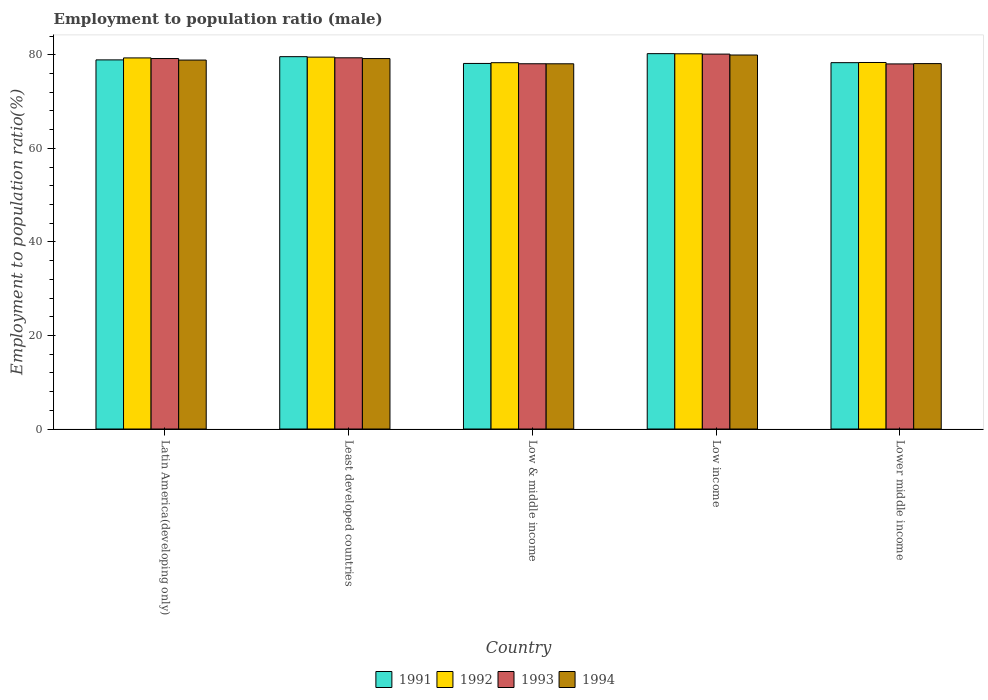How many groups of bars are there?
Offer a very short reply. 5. Are the number of bars per tick equal to the number of legend labels?
Ensure brevity in your answer.  Yes. How many bars are there on the 2nd tick from the right?
Give a very brief answer. 4. What is the label of the 5th group of bars from the left?
Provide a short and direct response. Lower middle income. In how many cases, is the number of bars for a given country not equal to the number of legend labels?
Offer a very short reply. 0. What is the employment to population ratio in 1991 in Lower middle income?
Offer a very short reply. 78.3. Across all countries, what is the maximum employment to population ratio in 1993?
Offer a very short reply. 80.14. Across all countries, what is the minimum employment to population ratio in 1993?
Offer a terse response. 78.04. In which country was the employment to population ratio in 1994 minimum?
Ensure brevity in your answer.  Low & middle income. What is the total employment to population ratio in 1992 in the graph?
Make the answer very short. 395.65. What is the difference between the employment to population ratio in 1993 in Least developed countries and that in Lower middle income?
Your response must be concise. 1.31. What is the difference between the employment to population ratio in 1993 in Low & middle income and the employment to population ratio in 1992 in Lower middle income?
Ensure brevity in your answer.  -0.27. What is the average employment to population ratio in 1991 per country?
Your answer should be compact. 79.03. What is the difference between the employment to population ratio of/in 1992 and employment to population ratio of/in 1993 in Latin America(developing only)?
Give a very brief answer. 0.14. What is the ratio of the employment to population ratio in 1991 in Low & middle income to that in Low income?
Your answer should be compact. 0.97. Is the difference between the employment to population ratio in 1992 in Low income and Lower middle income greater than the difference between the employment to population ratio in 1993 in Low income and Lower middle income?
Your response must be concise. No. What is the difference between the highest and the second highest employment to population ratio in 1993?
Give a very brief answer. 0.95. What is the difference between the highest and the lowest employment to population ratio in 1994?
Your answer should be compact. 1.88. In how many countries, is the employment to population ratio in 1991 greater than the average employment to population ratio in 1991 taken over all countries?
Offer a terse response. 2. Is the sum of the employment to population ratio in 1991 in Latin America(developing only) and Lower middle income greater than the maximum employment to population ratio in 1993 across all countries?
Provide a succinct answer. Yes. What does the 3rd bar from the left in Least developed countries represents?
Make the answer very short. 1993. Does the graph contain grids?
Your response must be concise. No. What is the title of the graph?
Ensure brevity in your answer.  Employment to population ratio (male). Does "1990" appear as one of the legend labels in the graph?
Your answer should be very brief. No. What is the label or title of the Y-axis?
Your answer should be compact. Employment to population ratio(%). What is the Employment to population ratio(%) of 1991 in Latin America(developing only)?
Make the answer very short. 78.9. What is the Employment to population ratio(%) of 1992 in Latin America(developing only)?
Give a very brief answer. 79.32. What is the Employment to population ratio(%) of 1993 in Latin America(developing only)?
Provide a short and direct response. 79.19. What is the Employment to population ratio(%) of 1994 in Latin America(developing only)?
Provide a succinct answer. 78.86. What is the Employment to population ratio(%) of 1991 in Least developed countries?
Provide a short and direct response. 79.59. What is the Employment to population ratio(%) in 1992 in Least developed countries?
Offer a very short reply. 79.49. What is the Employment to population ratio(%) of 1993 in Least developed countries?
Keep it short and to the point. 79.34. What is the Employment to population ratio(%) of 1994 in Least developed countries?
Your answer should be very brief. 79.18. What is the Employment to population ratio(%) in 1991 in Low & middle income?
Your answer should be compact. 78.14. What is the Employment to population ratio(%) of 1992 in Low & middle income?
Provide a short and direct response. 78.3. What is the Employment to population ratio(%) of 1993 in Low & middle income?
Your response must be concise. 78.07. What is the Employment to population ratio(%) of 1994 in Low & middle income?
Provide a short and direct response. 78.06. What is the Employment to population ratio(%) in 1991 in Low income?
Keep it short and to the point. 80.23. What is the Employment to population ratio(%) in 1992 in Low income?
Keep it short and to the point. 80.2. What is the Employment to population ratio(%) of 1993 in Low income?
Ensure brevity in your answer.  80.14. What is the Employment to population ratio(%) in 1994 in Low income?
Your answer should be compact. 79.94. What is the Employment to population ratio(%) of 1991 in Lower middle income?
Your answer should be compact. 78.3. What is the Employment to population ratio(%) in 1992 in Lower middle income?
Your answer should be very brief. 78.34. What is the Employment to population ratio(%) in 1993 in Lower middle income?
Give a very brief answer. 78.04. What is the Employment to population ratio(%) of 1994 in Lower middle income?
Your answer should be very brief. 78.11. Across all countries, what is the maximum Employment to population ratio(%) in 1991?
Your answer should be compact. 80.23. Across all countries, what is the maximum Employment to population ratio(%) of 1992?
Give a very brief answer. 80.2. Across all countries, what is the maximum Employment to population ratio(%) of 1993?
Your response must be concise. 80.14. Across all countries, what is the maximum Employment to population ratio(%) in 1994?
Your response must be concise. 79.94. Across all countries, what is the minimum Employment to population ratio(%) in 1991?
Keep it short and to the point. 78.14. Across all countries, what is the minimum Employment to population ratio(%) in 1992?
Your answer should be very brief. 78.3. Across all countries, what is the minimum Employment to population ratio(%) in 1993?
Keep it short and to the point. 78.04. Across all countries, what is the minimum Employment to population ratio(%) in 1994?
Offer a very short reply. 78.06. What is the total Employment to population ratio(%) in 1991 in the graph?
Keep it short and to the point. 395.16. What is the total Employment to population ratio(%) of 1992 in the graph?
Keep it short and to the point. 395.65. What is the total Employment to population ratio(%) of 1993 in the graph?
Offer a very short reply. 394.78. What is the total Employment to population ratio(%) in 1994 in the graph?
Provide a short and direct response. 394.15. What is the difference between the Employment to population ratio(%) in 1991 in Latin America(developing only) and that in Least developed countries?
Your answer should be very brief. -0.69. What is the difference between the Employment to population ratio(%) in 1992 in Latin America(developing only) and that in Least developed countries?
Ensure brevity in your answer.  -0.17. What is the difference between the Employment to population ratio(%) of 1993 in Latin America(developing only) and that in Least developed countries?
Provide a succinct answer. -0.16. What is the difference between the Employment to population ratio(%) of 1994 in Latin America(developing only) and that in Least developed countries?
Provide a short and direct response. -0.32. What is the difference between the Employment to population ratio(%) of 1991 in Latin America(developing only) and that in Low & middle income?
Your answer should be very brief. 0.76. What is the difference between the Employment to population ratio(%) of 1992 in Latin America(developing only) and that in Low & middle income?
Make the answer very short. 1.02. What is the difference between the Employment to population ratio(%) of 1993 in Latin America(developing only) and that in Low & middle income?
Provide a succinct answer. 1.11. What is the difference between the Employment to population ratio(%) in 1994 in Latin America(developing only) and that in Low & middle income?
Your response must be concise. 0.79. What is the difference between the Employment to population ratio(%) in 1991 in Latin America(developing only) and that in Low income?
Your answer should be very brief. -1.33. What is the difference between the Employment to population ratio(%) of 1992 in Latin America(developing only) and that in Low income?
Your answer should be compact. -0.88. What is the difference between the Employment to population ratio(%) of 1993 in Latin America(developing only) and that in Low income?
Offer a very short reply. -0.95. What is the difference between the Employment to population ratio(%) of 1994 in Latin America(developing only) and that in Low income?
Offer a terse response. -1.08. What is the difference between the Employment to population ratio(%) in 1991 in Latin America(developing only) and that in Lower middle income?
Offer a terse response. 0.59. What is the difference between the Employment to population ratio(%) of 1992 in Latin America(developing only) and that in Lower middle income?
Your response must be concise. 0.98. What is the difference between the Employment to population ratio(%) in 1993 in Latin America(developing only) and that in Lower middle income?
Your response must be concise. 1.15. What is the difference between the Employment to population ratio(%) of 1994 in Latin America(developing only) and that in Lower middle income?
Provide a succinct answer. 0.75. What is the difference between the Employment to population ratio(%) in 1991 in Least developed countries and that in Low & middle income?
Keep it short and to the point. 1.45. What is the difference between the Employment to population ratio(%) of 1992 in Least developed countries and that in Low & middle income?
Your answer should be very brief. 1.19. What is the difference between the Employment to population ratio(%) in 1993 in Least developed countries and that in Low & middle income?
Provide a succinct answer. 1.27. What is the difference between the Employment to population ratio(%) of 1994 in Least developed countries and that in Low & middle income?
Make the answer very short. 1.12. What is the difference between the Employment to population ratio(%) of 1991 in Least developed countries and that in Low income?
Your answer should be very brief. -0.65. What is the difference between the Employment to population ratio(%) in 1992 in Least developed countries and that in Low income?
Offer a terse response. -0.71. What is the difference between the Employment to population ratio(%) in 1993 in Least developed countries and that in Low income?
Offer a terse response. -0.79. What is the difference between the Employment to population ratio(%) of 1994 in Least developed countries and that in Low income?
Offer a terse response. -0.76. What is the difference between the Employment to population ratio(%) in 1991 in Least developed countries and that in Lower middle income?
Offer a terse response. 1.28. What is the difference between the Employment to population ratio(%) in 1992 in Least developed countries and that in Lower middle income?
Provide a succinct answer. 1.15. What is the difference between the Employment to population ratio(%) in 1993 in Least developed countries and that in Lower middle income?
Provide a short and direct response. 1.31. What is the difference between the Employment to population ratio(%) in 1994 in Least developed countries and that in Lower middle income?
Your answer should be compact. 1.07. What is the difference between the Employment to population ratio(%) of 1991 in Low & middle income and that in Low income?
Provide a succinct answer. -2.1. What is the difference between the Employment to population ratio(%) of 1992 in Low & middle income and that in Low income?
Your response must be concise. -1.9. What is the difference between the Employment to population ratio(%) of 1993 in Low & middle income and that in Low income?
Give a very brief answer. -2.06. What is the difference between the Employment to population ratio(%) in 1994 in Low & middle income and that in Low income?
Provide a short and direct response. -1.88. What is the difference between the Employment to population ratio(%) of 1991 in Low & middle income and that in Lower middle income?
Give a very brief answer. -0.17. What is the difference between the Employment to population ratio(%) of 1992 in Low & middle income and that in Lower middle income?
Your answer should be compact. -0.04. What is the difference between the Employment to population ratio(%) in 1993 in Low & middle income and that in Lower middle income?
Offer a terse response. 0.04. What is the difference between the Employment to population ratio(%) of 1994 in Low & middle income and that in Lower middle income?
Offer a very short reply. -0.04. What is the difference between the Employment to population ratio(%) in 1991 in Low income and that in Lower middle income?
Make the answer very short. 1.93. What is the difference between the Employment to population ratio(%) in 1992 in Low income and that in Lower middle income?
Offer a terse response. 1.86. What is the difference between the Employment to population ratio(%) of 1993 in Low income and that in Lower middle income?
Your answer should be very brief. 2.1. What is the difference between the Employment to population ratio(%) in 1994 in Low income and that in Lower middle income?
Make the answer very short. 1.84. What is the difference between the Employment to population ratio(%) of 1991 in Latin America(developing only) and the Employment to population ratio(%) of 1992 in Least developed countries?
Provide a short and direct response. -0.59. What is the difference between the Employment to population ratio(%) in 1991 in Latin America(developing only) and the Employment to population ratio(%) in 1993 in Least developed countries?
Give a very brief answer. -0.45. What is the difference between the Employment to population ratio(%) of 1991 in Latin America(developing only) and the Employment to population ratio(%) of 1994 in Least developed countries?
Ensure brevity in your answer.  -0.28. What is the difference between the Employment to population ratio(%) in 1992 in Latin America(developing only) and the Employment to population ratio(%) in 1993 in Least developed countries?
Keep it short and to the point. -0.02. What is the difference between the Employment to population ratio(%) of 1992 in Latin America(developing only) and the Employment to population ratio(%) of 1994 in Least developed countries?
Offer a terse response. 0.14. What is the difference between the Employment to population ratio(%) in 1993 in Latin America(developing only) and the Employment to population ratio(%) in 1994 in Least developed countries?
Offer a very short reply. 0.01. What is the difference between the Employment to population ratio(%) in 1991 in Latin America(developing only) and the Employment to population ratio(%) in 1992 in Low & middle income?
Keep it short and to the point. 0.6. What is the difference between the Employment to population ratio(%) of 1991 in Latin America(developing only) and the Employment to population ratio(%) of 1993 in Low & middle income?
Offer a very short reply. 0.83. What is the difference between the Employment to population ratio(%) of 1991 in Latin America(developing only) and the Employment to population ratio(%) of 1994 in Low & middle income?
Provide a short and direct response. 0.83. What is the difference between the Employment to population ratio(%) in 1992 in Latin America(developing only) and the Employment to population ratio(%) in 1993 in Low & middle income?
Keep it short and to the point. 1.25. What is the difference between the Employment to population ratio(%) of 1992 in Latin America(developing only) and the Employment to population ratio(%) of 1994 in Low & middle income?
Offer a terse response. 1.26. What is the difference between the Employment to population ratio(%) in 1993 in Latin America(developing only) and the Employment to population ratio(%) in 1994 in Low & middle income?
Make the answer very short. 1.12. What is the difference between the Employment to population ratio(%) of 1991 in Latin America(developing only) and the Employment to population ratio(%) of 1992 in Low income?
Your answer should be very brief. -1.3. What is the difference between the Employment to population ratio(%) in 1991 in Latin America(developing only) and the Employment to population ratio(%) in 1993 in Low income?
Provide a succinct answer. -1.24. What is the difference between the Employment to population ratio(%) of 1991 in Latin America(developing only) and the Employment to population ratio(%) of 1994 in Low income?
Make the answer very short. -1.04. What is the difference between the Employment to population ratio(%) of 1992 in Latin America(developing only) and the Employment to population ratio(%) of 1993 in Low income?
Make the answer very short. -0.81. What is the difference between the Employment to population ratio(%) in 1992 in Latin America(developing only) and the Employment to population ratio(%) in 1994 in Low income?
Provide a short and direct response. -0.62. What is the difference between the Employment to population ratio(%) in 1993 in Latin America(developing only) and the Employment to population ratio(%) in 1994 in Low income?
Give a very brief answer. -0.76. What is the difference between the Employment to population ratio(%) of 1991 in Latin America(developing only) and the Employment to population ratio(%) of 1992 in Lower middle income?
Offer a terse response. 0.56. What is the difference between the Employment to population ratio(%) in 1991 in Latin America(developing only) and the Employment to population ratio(%) in 1993 in Lower middle income?
Give a very brief answer. 0.86. What is the difference between the Employment to population ratio(%) in 1991 in Latin America(developing only) and the Employment to population ratio(%) in 1994 in Lower middle income?
Offer a very short reply. 0.79. What is the difference between the Employment to population ratio(%) in 1992 in Latin America(developing only) and the Employment to population ratio(%) in 1993 in Lower middle income?
Your response must be concise. 1.28. What is the difference between the Employment to population ratio(%) of 1992 in Latin America(developing only) and the Employment to population ratio(%) of 1994 in Lower middle income?
Your answer should be compact. 1.22. What is the difference between the Employment to population ratio(%) in 1993 in Latin America(developing only) and the Employment to population ratio(%) in 1994 in Lower middle income?
Your response must be concise. 1.08. What is the difference between the Employment to population ratio(%) of 1991 in Least developed countries and the Employment to population ratio(%) of 1992 in Low & middle income?
Make the answer very short. 1.29. What is the difference between the Employment to population ratio(%) in 1991 in Least developed countries and the Employment to population ratio(%) in 1993 in Low & middle income?
Provide a succinct answer. 1.51. What is the difference between the Employment to population ratio(%) of 1991 in Least developed countries and the Employment to population ratio(%) of 1994 in Low & middle income?
Keep it short and to the point. 1.52. What is the difference between the Employment to population ratio(%) in 1992 in Least developed countries and the Employment to population ratio(%) in 1993 in Low & middle income?
Provide a short and direct response. 1.42. What is the difference between the Employment to population ratio(%) in 1992 in Least developed countries and the Employment to population ratio(%) in 1994 in Low & middle income?
Offer a terse response. 1.43. What is the difference between the Employment to population ratio(%) of 1993 in Least developed countries and the Employment to population ratio(%) of 1994 in Low & middle income?
Offer a very short reply. 1.28. What is the difference between the Employment to population ratio(%) of 1991 in Least developed countries and the Employment to population ratio(%) of 1992 in Low income?
Make the answer very short. -0.61. What is the difference between the Employment to population ratio(%) in 1991 in Least developed countries and the Employment to population ratio(%) in 1993 in Low income?
Your answer should be compact. -0.55. What is the difference between the Employment to population ratio(%) of 1991 in Least developed countries and the Employment to population ratio(%) of 1994 in Low income?
Make the answer very short. -0.35. What is the difference between the Employment to population ratio(%) in 1992 in Least developed countries and the Employment to population ratio(%) in 1993 in Low income?
Your response must be concise. -0.65. What is the difference between the Employment to population ratio(%) of 1992 in Least developed countries and the Employment to population ratio(%) of 1994 in Low income?
Keep it short and to the point. -0.45. What is the difference between the Employment to population ratio(%) of 1993 in Least developed countries and the Employment to population ratio(%) of 1994 in Low income?
Provide a succinct answer. -0.6. What is the difference between the Employment to population ratio(%) in 1991 in Least developed countries and the Employment to population ratio(%) in 1992 in Lower middle income?
Give a very brief answer. 1.25. What is the difference between the Employment to population ratio(%) of 1991 in Least developed countries and the Employment to population ratio(%) of 1993 in Lower middle income?
Keep it short and to the point. 1.55. What is the difference between the Employment to population ratio(%) in 1991 in Least developed countries and the Employment to population ratio(%) in 1994 in Lower middle income?
Make the answer very short. 1.48. What is the difference between the Employment to population ratio(%) in 1992 in Least developed countries and the Employment to population ratio(%) in 1993 in Lower middle income?
Your answer should be compact. 1.45. What is the difference between the Employment to population ratio(%) of 1992 in Least developed countries and the Employment to population ratio(%) of 1994 in Lower middle income?
Offer a terse response. 1.38. What is the difference between the Employment to population ratio(%) of 1993 in Least developed countries and the Employment to population ratio(%) of 1994 in Lower middle income?
Offer a very short reply. 1.24. What is the difference between the Employment to population ratio(%) in 1991 in Low & middle income and the Employment to population ratio(%) in 1992 in Low income?
Make the answer very short. -2.06. What is the difference between the Employment to population ratio(%) in 1991 in Low & middle income and the Employment to population ratio(%) in 1993 in Low income?
Offer a terse response. -2. What is the difference between the Employment to population ratio(%) in 1991 in Low & middle income and the Employment to population ratio(%) in 1994 in Low income?
Your answer should be very brief. -1.8. What is the difference between the Employment to population ratio(%) in 1992 in Low & middle income and the Employment to population ratio(%) in 1993 in Low income?
Your answer should be compact. -1.84. What is the difference between the Employment to population ratio(%) of 1992 in Low & middle income and the Employment to population ratio(%) of 1994 in Low income?
Offer a terse response. -1.64. What is the difference between the Employment to population ratio(%) in 1993 in Low & middle income and the Employment to population ratio(%) in 1994 in Low income?
Provide a succinct answer. -1.87. What is the difference between the Employment to population ratio(%) of 1991 in Low & middle income and the Employment to population ratio(%) of 1992 in Lower middle income?
Your response must be concise. -0.21. What is the difference between the Employment to population ratio(%) in 1991 in Low & middle income and the Employment to population ratio(%) in 1993 in Lower middle income?
Offer a terse response. 0.1. What is the difference between the Employment to population ratio(%) in 1991 in Low & middle income and the Employment to population ratio(%) in 1994 in Lower middle income?
Offer a very short reply. 0.03. What is the difference between the Employment to population ratio(%) in 1992 in Low & middle income and the Employment to population ratio(%) in 1993 in Lower middle income?
Your response must be concise. 0.26. What is the difference between the Employment to population ratio(%) in 1992 in Low & middle income and the Employment to population ratio(%) in 1994 in Lower middle income?
Your answer should be compact. 0.19. What is the difference between the Employment to population ratio(%) in 1993 in Low & middle income and the Employment to population ratio(%) in 1994 in Lower middle income?
Ensure brevity in your answer.  -0.03. What is the difference between the Employment to population ratio(%) of 1991 in Low income and the Employment to population ratio(%) of 1992 in Lower middle income?
Your answer should be compact. 1.89. What is the difference between the Employment to population ratio(%) in 1991 in Low income and the Employment to population ratio(%) in 1993 in Lower middle income?
Make the answer very short. 2.2. What is the difference between the Employment to population ratio(%) in 1991 in Low income and the Employment to population ratio(%) in 1994 in Lower middle income?
Give a very brief answer. 2.13. What is the difference between the Employment to population ratio(%) of 1992 in Low income and the Employment to population ratio(%) of 1993 in Lower middle income?
Provide a succinct answer. 2.16. What is the difference between the Employment to population ratio(%) in 1992 in Low income and the Employment to population ratio(%) in 1994 in Lower middle income?
Keep it short and to the point. 2.1. What is the difference between the Employment to population ratio(%) of 1993 in Low income and the Employment to population ratio(%) of 1994 in Lower middle income?
Provide a succinct answer. 2.03. What is the average Employment to population ratio(%) of 1991 per country?
Give a very brief answer. 79.03. What is the average Employment to population ratio(%) of 1992 per country?
Make the answer very short. 79.13. What is the average Employment to population ratio(%) of 1993 per country?
Provide a succinct answer. 78.96. What is the average Employment to population ratio(%) of 1994 per country?
Provide a succinct answer. 78.83. What is the difference between the Employment to population ratio(%) in 1991 and Employment to population ratio(%) in 1992 in Latin America(developing only)?
Give a very brief answer. -0.42. What is the difference between the Employment to population ratio(%) in 1991 and Employment to population ratio(%) in 1993 in Latin America(developing only)?
Keep it short and to the point. -0.29. What is the difference between the Employment to population ratio(%) of 1991 and Employment to population ratio(%) of 1994 in Latin America(developing only)?
Ensure brevity in your answer.  0.04. What is the difference between the Employment to population ratio(%) in 1992 and Employment to population ratio(%) in 1993 in Latin America(developing only)?
Give a very brief answer. 0.14. What is the difference between the Employment to population ratio(%) of 1992 and Employment to population ratio(%) of 1994 in Latin America(developing only)?
Your answer should be very brief. 0.46. What is the difference between the Employment to population ratio(%) in 1993 and Employment to population ratio(%) in 1994 in Latin America(developing only)?
Provide a short and direct response. 0.33. What is the difference between the Employment to population ratio(%) in 1991 and Employment to population ratio(%) in 1992 in Least developed countries?
Your response must be concise. 0.1. What is the difference between the Employment to population ratio(%) of 1991 and Employment to population ratio(%) of 1993 in Least developed countries?
Offer a very short reply. 0.24. What is the difference between the Employment to population ratio(%) in 1991 and Employment to population ratio(%) in 1994 in Least developed countries?
Provide a short and direct response. 0.41. What is the difference between the Employment to population ratio(%) in 1992 and Employment to population ratio(%) in 1993 in Least developed countries?
Ensure brevity in your answer.  0.15. What is the difference between the Employment to population ratio(%) in 1992 and Employment to population ratio(%) in 1994 in Least developed countries?
Offer a very short reply. 0.31. What is the difference between the Employment to population ratio(%) of 1993 and Employment to population ratio(%) of 1994 in Least developed countries?
Ensure brevity in your answer.  0.17. What is the difference between the Employment to population ratio(%) in 1991 and Employment to population ratio(%) in 1992 in Low & middle income?
Make the answer very short. -0.16. What is the difference between the Employment to population ratio(%) in 1991 and Employment to population ratio(%) in 1993 in Low & middle income?
Your answer should be very brief. 0.06. What is the difference between the Employment to population ratio(%) in 1991 and Employment to population ratio(%) in 1994 in Low & middle income?
Your answer should be very brief. 0.07. What is the difference between the Employment to population ratio(%) of 1992 and Employment to population ratio(%) of 1993 in Low & middle income?
Offer a terse response. 0.22. What is the difference between the Employment to population ratio(%) of 1992 and Employment to population ratio(%) of 1994 in Low & middle income?
Offer a terse response. 0.23. What is the difference between the Employment to population ratio(%) in 1993 and Employment to population ratio(%) in 1994 in Low & middle income?
Offer a terse response. 0.01. What is the difference between the Employment to population ratio(%) in 1991 and Employment to population ratio(%) in 1992 in Low income?
Offer a very short reply. 0.03. What is the difference between the Employment to population ratio(%) in 1991 and Employment to population ratio(%) in 1993 in Low income?
Provide a succinct answer. 0.1. What is the difference between the Employment to population ratio(%) in 1991 and Employment to population ratio(%) in 1994 in Low income?
Give a very brief answer. 0.29. What is the difference between the Employment to population ratio(%) in 1992 and Employment to population ratio(%) in 1993 in Low income?
Your response must be concise. 0.06. What is the difference between the Employment to population ratio(%) in 1992 and Employment to population ratio(%) in 1994 in Low income?
Ensure brevity in your answer.  0.26. What is the difference between the Employment to population ratio(%) of 1993 and Employment to population ratio(%) of 1994 in Low income?
Your answer should be compact. 0.19. What is the difference between the Employment to population ratio(%) in 1991 and Employment to population ratio(%) in 1992 in Lower middle income?
Keep it short and to the point. -0.04. What is the difference between the Employment to population ratio(%) of 1991 and Employment to population ratio(%) of 1993 in Lower middle income?
Keep it short and to the point. 0.27. What is the difference between the Employment to population ratio(%) in 1991 and Employment to population ratio(%) in 1994 in Lower middle income?
Your response must be concise. 0.2. What is the difference between the Employment to population ratio(%) of 1992 and Employment to population ratio(%) of 1993 in Lower middle income?
Provide a succinct answer. 0.3. What is the difference between the Employment to population ratio(%) in 1992 and Employment to population ratio(%) in 1994 in Lower middle income?
Your answer should be very brief. 0.24. What is the difference between the Employment to population ratio(%) in 1993 and Employment to population ratio(%) in 1994 in Lower middle income?
Keep it short and to the point. -0.07. What is the ratio of the Employment to population ratio(%) in 1991 in Latin America(developing only) to that in Least developed countries?
Offer a very short reply. 0.99. What is the ratio of the Employment to population ratio(%) of 1991 in Latin America(developing only) to that in Low & middle income?
Keep it short and to the point. 1.01. What is the ratio of the Employment to population ratio(%) of 1992 in Latin America(developing only) to that in Low & middle income?
Ensure brevity in your answer.  1.01. What is the ratio of the Employment to population ratio(%) in 1993 in Latin America(developing only) to that in Low & middle income?
Make the answer very short. 1.01. What is the ratio of the Employment to population ratio(%) in 1994 in Latin America(developing only) to that in Low & middle income?
Provide a succinct answer. 1.01. What is the ratio of the Employment to population ratio(%) of 1991 in Latin America(developing only) to that in Low income?
Provide a succinct answer. 0.98. What is the ratio of the Employment to population ratio(%) of 1992 in Latin America(developing only) to that in Low income?
Your answer should be compact. 0.99. What is the ratio of the Employment to population ratio(%) in 1993 in Latin America(developing only) to that in Low income?
Make the answer very short. 0.99. What is the ratio of the Employment to population ratio(%) in 1994 in Latin America(developing only) to that in Low income?
Ensure brevity in your answer.  0.99. What is the ratio of the Employment to population ratio(%) of 1991 in Latin America(developing only) to that in Lower middle income?
Keep it short and to the point. 1.01. What is the ratio of the Employment to population ratio(%) of 1992 in Latin America(developing only) to that in Lower middle income?
Offer a terse response. 1.01. What is the ratio of the Employment to population ratio(%) in 1993 in Latin America(developing only) to that in Lower middle income?
Provide a succinct answer. 1.01. What is the ratio of the Employment to population ratio(%) in 1994 in Latin America(developing only) to that in Lower middle income?
Your response must be concise. 1.01. What is the ratio of the Employment to population ratio(%) of 1991 in Least developed countries to that in Low & middle income?
Keep it short and to the point. 1.02. What is the ratio of the Employment to population ratio(%) of 1992 in Least developed countries to that in Low & middle income?
Give a very brief answer. 1.02. What is the ratio of the Employment to population ratio(%) in 1993 in Least developed countries to that in Low & middle income?
Make the answer very short. 1.02. What is the ratio of the Employment to population ratio(%) of 1994 in Least developed countries to that in Low & middle income?
Offer a very short reply. 1.01. What is the ratio of the Employment to population ratio(%) in 1991 in Least developed countries to that in Low income?
Provide a short and direct response. 0.99. What is the ratio of the Employment to population ratio(%) in 1992 in Least developed countries to that in Low income?
Provide a succinct answer. 0.99. What is the ratio of the Employment to population ratio(%) of 1993 in Least developed countries to that in Low income?
Keep it short and to the point. 0.99. What is the ratio of the Employment to population ratio(%) of 1994 in Least developed countries to that in Low income?
Your answer should be compact. 0.99. What is the ratio of the Employment to population ratio(%) in 1991 in Least developed countries to that in Lower middle income?
Offer a very short reply. 1.02. What is the ratio of the Employment to population ratio(%) in 1992 in Least developed countries to that in Lower middle income?
Offer a terse response. 1.01. What is the ratio of the Employment to population ratio(%) of 1993 in Least developed countries to that in Lower middle income?
Give a very brief answer. 1.02. What is the ratio of the Employment to population ratio(%) of 1994 in Least developed countries to that in Lower middle income?
Your response must be concise. 1.01. What is the ratio of the Employment to population ratio(%) of 1991 in Low & middle income to that in Low income?
Offer a terse response. 0.97. What is the ratio of the Employment to population ratio(%) in 1992 in Low & middle income to that in Low income?
Keep it short and to the point. 0.98. What is the ratio of the Employment to population ratio(%) in 1993 in Low & middle income to that in Low income?
Your answer should be compact. 0.97. What is the ratio of the Employment to population ratio(%) of 1994 in Low & middle income to that in Low income?
Keep it short and to the point. 0.98. What is the ratio of the Employment to population ratio(%) in 1993 in Low & middle income to that in Lower middle income?
Provide a short and direct response. 1. What is the ratio of the Employment to population ratio(%) of 1994 in Low & middle income to that in Lower middle income?
Ensure brevity in your answer.  1. What is the ratio of the Employment to population ratio(%) in 1991 in Low income to that in Lower middle income?
Your answer should be very brief. 1.02. What is the ratio of the Employment to population ratio(%) in 1992 in Low income to that in Lower middle income?
Give a very brief answer. 1.02. What is the ratio of the Employment to population ratio(%) of 1993 in Low income to that in Lower middle income?
Your answer should be very brief. 1.03. What is the ratio of the Employment to population ratio(%) in 1994 in Low income to that in Lower middle income?
Keep it short and to the point. 1.02. What is the difference between the highest and the second highest Employment to population ratio(%) of 1991?
Your answer should be compact. 0.65. What is the difference between the highest and the second highest Employment to population ratio(%) in 1992?
Ensure brevity in your answer.  0.71. What is the difference between the highest and the second highest Employment to population ratio(%) of 1993?
Your answer should be compact. 0.79. What is the difference between the highest and the second highest Employment to population ratio(%) in 1994?
Give a very brief answer. 0.76. What is the difference between the highest and the lowest Employment to population ratio(%) of 1991?
Provide a short and direct response. 2.1. What is the difference between the highest and the lowest Employment to population ratio(%) of 1992?
Your answer should be compact. 1.9. What is the difference between the highest and the lowest Employment to population ratio(%) in 1993?
Provide a succinct answer. 2.1. What is the difference between the highest and the lowest Employment to population ratio(%) of 1994?
Ensure brevity in your answer.  1.88. 